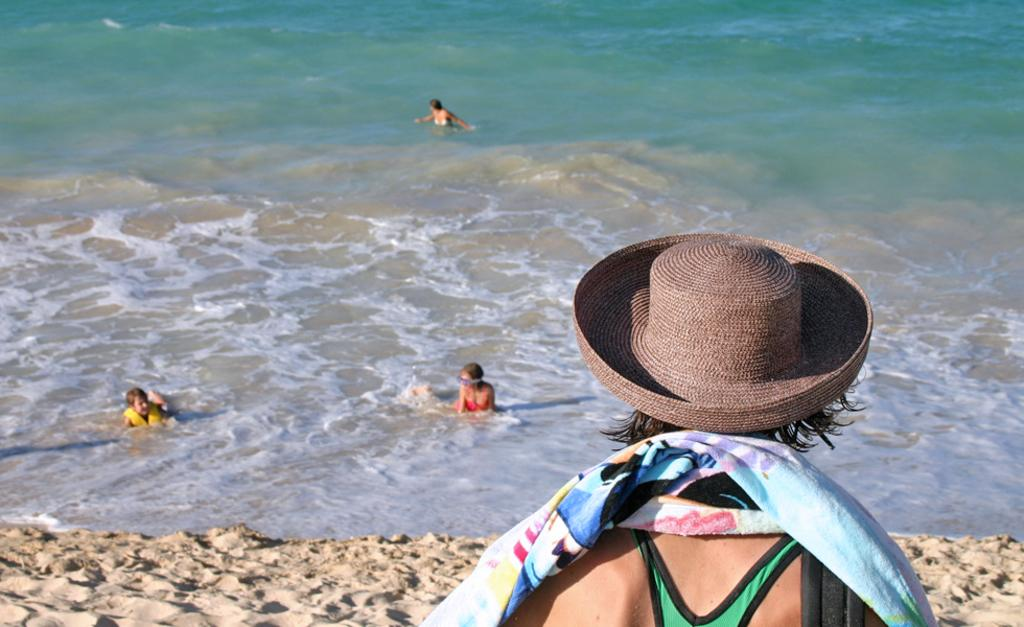What type of terrain is visible in the image? There is sand in the image. How many people are present in the image? There are four people in the image. What can be seen in the background of the image? There is water visible in the background of the image. What type of camera is being used by the people in the image? There is no camera visible in the image, and it is not mentioned that the people are using one. Is there a river visible in the image? The provided facts do not mention a river, only water visible in the background. 